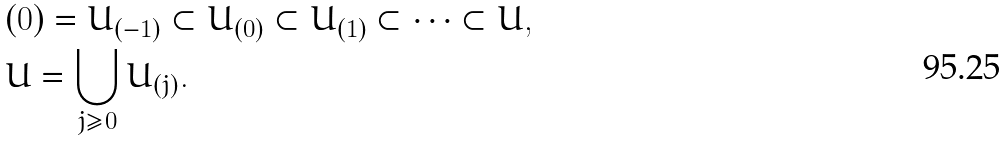Convert formula to latex. <formula><loc_0><loc_0><loc_500><loc_500>& ( 0 ) = U _ { ( - 1 ) } \subset U _ { ( 0 ) } \subset U _ { ( 1 ) } \subset \dots \subset U , \\ & U = \bigcup _ { j \geq 0 } U _ { ( j ) } .</formula> 